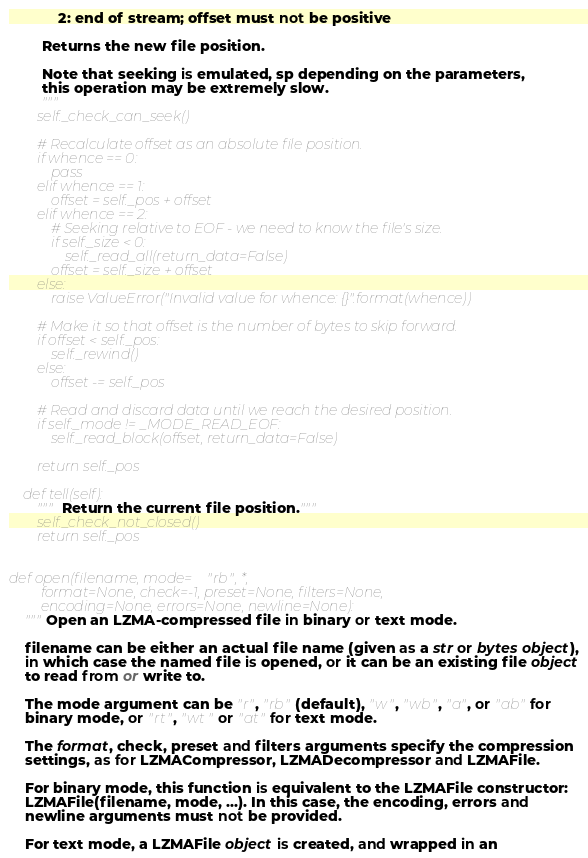<code> <loc_0><loc_0><loc_500><loc_500><_Python_>            2: end of stream; offset must not be positive

        Returns the new file position.

        Note that seeking is emulated, sp depending on the parameters,
        this operation may be extremely slow.
        """
        self._check_can_seek()

        # Recalculate offset as an absolute file position.
        if whence == 0:
            pass
        elif whence == 1:
            offset = self._pos + offset
        elif whence == 2:
            # Seeking relative to EOF - we need to know the file's size.
            if self._size < 0:
                self._read_all(return_data=False)
            offset = self._size + offset
        else:
            raise ValueError("Invalid value for whence: {}".format(whence))

        # Make it so that offset is the number of bytes to skip forward.
        if offset < self._pos:
            self._rewind()
        else:
            offset -= self._pos

        # Read and discard data until we reach the desired position.
        if self._mode != _MODE_READ_EOF:
            self._read_block(offset, return_data=False)

        return self._pos

    def tell(self):
        """Return the current file position."""
        self._check_not_closed()
        return self._pos


def open(filename, mode="rb", *,
         format=None, check=-1, preset=None, filters=None,
         encoding=None, errors=None, newline=None):
    """Open an LZMA-compressed file in binary or text mode.

    filename can be either an actual file name (given as a str or bytes object),
    in which case the named file is opened, or it can be an existing file object
    to read from or write to.

    The mode argument can be "r", "rb" (default), "w", "wb", "a", or "ab" for
    binary mode, or "rt", "wt" or "at" for text mode.

    The format, check, preset and filters arguments specify the compression
    settings, as for LZMACompressor, LZMADecompressor and LZMAFile.

    For binary mode, this function is equivalent to the LZMAFile constructor:
    LZMAFile(filename, mode, ...). In this case, the encoding, errors and
    newline arguments must not be provided.

    For text mode, a LZMAFile object is created, and wrapped in an</code> 